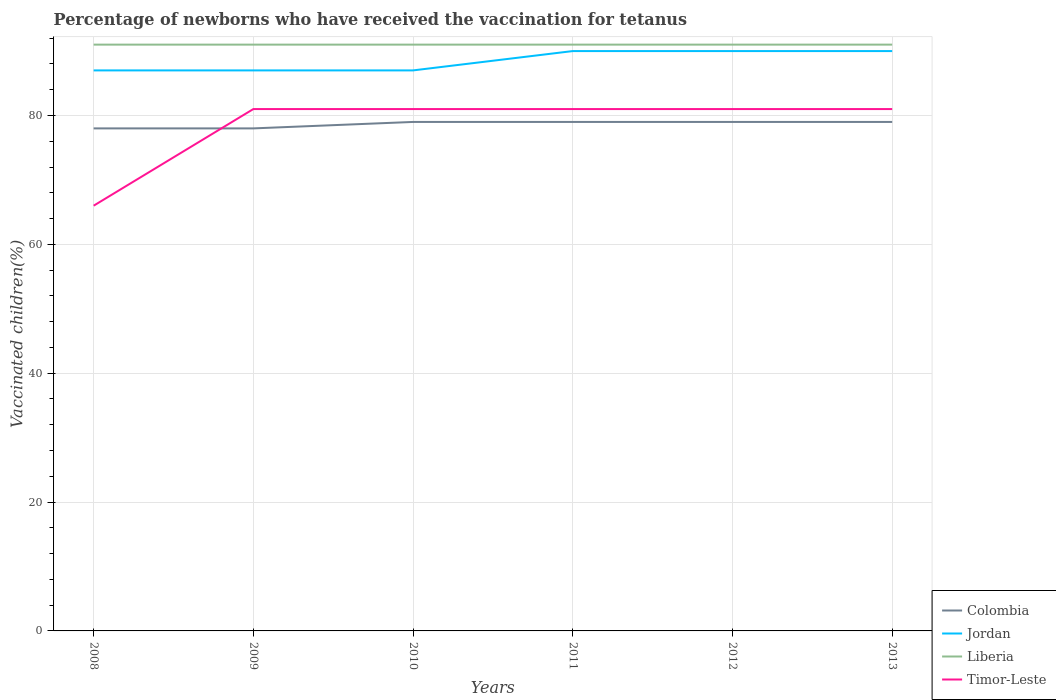How many lines are there?
Offer a very short reply. 4. Does the graph contain any zero values?
Your answer should be very brief. No. Where does the legend appear in the graph?
Your response must be concise. Bottom right. What is the title of the graph?
Give a very brief answer. Percentage of newborns who have received the vaccination for tetanus. Does "Nicaragua" appear as one of the legend labels in the graph?
Offer a very short reply. No. What is the label or title of the Y-axis?
Offer a terse response. Vaccinated children(%). What is the Vaccinated children(%) of Jordan in 2008?
Your response must be concise. 87. What is the Vaccinated children(%) of Liberia in 2008?
Your answer should be compact. 91. What is the Vaccinated children(%) of Liberia in 2009?
Give a very brief answer. 91. What is the Vaccinated children(%) of Timor-Leste in 2009?
Ensure brevity in your answer.  81. What is the Vaccinated children(%) of Colombia in 2010?
Your response must be concise. 79. What is the Vaccinated children(%) in Liberia in 2010?
Provide a succinct answer. 91. What is the Vaccinated children(%) of Timor-Leste in 2010?
Make the answer very short. 81. What is the Vaccinated children(%) in Colombia in 2011?
Make the answer very short. 79. What is the Vaccinated children(%) of Liberia in 2011?
Your answer should be compact. 91. What is the Vaccinated children(%) in Timor-Leste in 2011?
Provide a succinct answer. 81. What is the Vaccinated children(%) of Colombia in 2012?
Provide a succinct answer. 79. What is the Vaccinated children(%) of Jordan in 2012?
Your response must be concise. 90. What is the Vaccinated children(%) in Liberia in 2012?
Your response must be concise. 91. What is the Vaccinated children(%) of Timor-Leste in 2012?
Make the answer very short. 81. What is the Vaccinated children(%) of Colombia in 2013?
Offer a very short reply. 79. What is the Vaccinated children(%) of Jordan in 2013?
Provide a succinct answer. 90. What is the Vaccinated children(%) in Liberia in 2013?
Provide a short and direct response. 91. Across all years, what is the maximum Vaccinated children(%) in Colombia?
Provide a short and direct response. 79. Across all years, what is the maximum Vaccinated children(%) of Liberia?
Provide a succinct answer. 91. Across all years, what is the minimum Vaccinated children(%) in Jordan?
Keep it short and to the point. 87. Across all years, what is the minimum Vaccinated children(%) of Liberia?
Make the answer very short. 91. What is the total Vaccinated children(%) in Colombia in the graph?
Make the answer very short. 472. What is the total Vaccinated children(%) of Jordan in the graph?
Keep it short and to the point. 531. What is the total Vaccinated children(%) of Liberia in the graph?
Provide a short and direct response. 546. What is the total Vaccinated children(%) in Timor-Leste in the graph?
Make the answer very short. 471. What is the difference between the Vaccinated children(%) in Colombia in 2008 and that in 2009?
Keep it short and to the point. 0. What is the difference between the Vaccinated children(%) of Jordan in 2008 and that in 2009?
Your answer should be very brief. 0. What is the difference between the Vaccinated children(%) in Liberia in 2008 and that in 2009?
Provide a succinct answer. 0. What is the difference between the Vaccinated children(%) of Colombia in 2008 and that in 2010?
Provide a succinct answer. -1. What is the difference between the Vaccinated children(%) in Jordan in 2008 and that in 2010?
Offer a terse response. 0. What is the difference between the Vaccinated children(%) in Timor-Leste in 2008 and that in 2010?
Your response must be concise. -15. What is the difference between the Vaccinated children(%) of Timor-Leste in 2008 and that in 2011?
Give a very brief answer. -15. What is the difference between the Vaccinated children(%) in Colombia in 2008 and that in 2012?
Offer a very short reply. -1. What is the difference between the Vaccinated children(%) of Jordan in 2008 and that in 2012?
Your answer should be compact. -3. What is the difference between the Vaccinated children(%) in Liberia in 2008 and that in 2012?
Offer a very short reply. 0. What is the difference between the Vaccinated children(%) of Timor-Leste in 2008 and that in 2012?
Offer a terse response. -15. What is the difference between the Vaccinated children(%) in Colombia in 2008 and that in 2013?
Ensure brevity in your answer.  -1. What is the difference between the Vaccinated children(%) of Colombia in 2009 and that in 2010?
Your answer should be very brief. -1. What is the difference between the Vaccinated children(%) in Jordan in 2009 and that in 2011?
Offer a terse response. -3. What is the difference between the Vaccinated children(%) in Liberia in 2009 and that in 2011?
Give a very brief answer. 0. What is the difference between the Vaccinated children(%) in Jordan in 2009 and that in 2012?
Offer a very short reply. -3. What is the difference between the Vaccinated children(%) of Liberia in 2009 and that in 2012?
Ensure brevity in your answer.  0. What is the difference between the Vaccinated children(%) in Timor-Leste in 2009 and that in 2012?
Offer a very short reply. 0. What is the difference between the Vaccinated children(%) in Colombia in 2009 and that in 2013?
Offer a terse response. -1. What is the difference between the Vaccinated children(%) of Jordan in 2009 and that in 2013?
Your answer should be compact. -3. What is the difference between the Vaccinated children(%) in Timor-Leste in 2009 and that in 2013?
Your answer should be very brief. 0. What is the difference between the Vaccinated children(%) of Colombia in 2010 and that in 2012?
Offer a very short reply. 0. What is the difference between the Vaccinated children(%) in Jordan in 2010 and that in 2012?
Your response must be concise. -3. What is the difference between the Vaccinated children(%) in Colombia in 2010 and that in 2013?
Offer a very short reply. 0. What is the difference between the Vaccinated children(%) of Jordan in 2010 and that in 2013?
Give a very brief answer. -3. What is the difference between the Vaccinated children(%) of Liberia in 2010 and that in 2013?
Give a very brief answer. 0. What is the difference between the Vaccinated children(%) in Jordan in 2011 and that in 2012?
Provide a short and direct response. 0. What is the difference between the Vaccinated children(%) of Colombia in 2012 and that in 2013?
Make the answer very short. 0. What is the difference between the Vaccinated children(%) of Jordan in 2012 and that in 2013?
Offer a terse response. 0. What is the difference between the Vaccinated children(%) in Liberia in 2012 and that in 2013?
Offer a terse response. 0. What is the difference between the Vaccinated children(%) of Timor-Leste in 2012 and that in 2013?
Keep it short and to the point. 0. What is the difference between the Vaccinated children(%) of Colombia in 2008 and the Vaccinated children(%) of Jordan in 2009?
Give a very brief answer. -9. What is the difference between the Vaccinated children(%) in Colombia in 2008 and the Vaccinated children(%) in Liberia in 2009?
Your response must be concise. -13. What is the difference between the Vaccinated children(%) of Colombia in 2008 and the Vaccinated children(%) of Timor-Leste in 2009?
Your answer should be very brief. -3. What is the difference between the Vaccinated children(%) of Liberia in 2008 and the Vaccinated children(%) of Timor-Leste in 2009?
Ensure brevity in your answer.  10. What is the difference between the Vaccinated children(%) in Colombia in 2008 and the Vaccinated children(%) in Timor-Leste in 2010?
Offer a terse response. -3. What is the difference between the Vaccinated children(%) of Jordan in 2008 and the Vaccinated children(%) of Timor-Leste in 2010?
Offer a very short reply. 6. What is the difference between the Vaccinated children(%) in Colombia in 2008 and the Vaccinated children(%) in Liberia in 2011?
Offer a very short reply. -13. What is the difference between the Vaccinated children(%) of Colombia in 2008 and the Vaccinated children(%) of Timor-Leste in 2011?
Offer a very short reply. -3. What is the difference between the Vaccinated children(%) in Jordan in 2008 and the Vaccinated children(%) in Timor-Leste in 2011?
Give a very brief answer. 6. What is the difference between the Vaccinated children(%) in Colombia in 2008 and the Vaccinated children(%) in Jordan in 2012?
Your answer should be compact. -12. What is the difference between the Vaccinated children(%) in Colombia in 2008 and the Vaccinated children(%) in Liberia in 2012?
Offer a terse response. -13. What is the difference between the Vaccinated children(%) of Colombia in 2008 and the Vaccinated children(%) of Timor-Leste in 2012?
Your response must be concise. -3. What is the difference between the Vaccinated children(%) of Jordan in 2008 and the Vaccinated children(%) of Timor-Leste in 2012?
Ensure brevity in your answer.  6. What is the difference between the Vaccinated children(%) in Liberia in 2008 and the Vaccinated children(%) in Timor-Leste in 2012?
Keep it short and to the point. 10. What is the difference between the Vaccinated children(%) of Colombia in 2008 and the Vaccinated children(%) of Liberia in 2013?
Your answer should be compact. -13. What is the difference between the Vaccinated children(%) of Colombia in 2008 and the Vaccinated children(%) of Timor-Leste in 2013?
Your answer should be compact. -3. What is the difference between the Vaccinated children(%) in Colombia in 2009 and the Vaccinated children(%) in Liberia in 2010?
Your answer should be compact. -13. What is the difference between the Vaccinated children(%) in Colombia in 2009 and the Vaccinated children(%) in Timor-Leste in 2010?
Offer a terse response. -3. What is the difference between the Vaccinated children(%) in Jordan in 2009 and the Vaccinated children(%) in Liberia in 2010?
Give a very brief answer. -4. What is the difference between the Vaccinated children(%) in Jordan in 2009 and the Vaccinated children(%) in Timor-Leste in 2010?
Keep it short and to the point. 6. What is the difference between the Vaccinated children(%) in Colombia in 2009 and the Vaccinated children(%) in Liberia in 2011?
Provide a short and direct response. -13. What is the difference between the Vaccinated children(%) of Colombia in 2009 and the Vaccinated children(%) of Timor-Leste in 2011?
Your answer should be very brief. -3. What is the difference between the Vaccinated children(%) of Jordan in 2009 and the Vaccinated children(%) of Timor-Leste in 2011?
Your answer should be very brief. 6. What is the difference between the Vaccinated children(%) in Liberia in 2009 and the Vaccinated children(%) in Timor-Leste in 2011?
Offer a very short reply. 10. What is the difference between the Vaccinated children(%) of Colombia in 2009 and the Vaccinated children(%) of Liberia in 2012?
Offer a terse response. -13. What is the difference between the Vaccinated children(%) in Colombia in 2009 and the Vaccinated children(%) in Timor-Leste in 2012?
Keep it short and to the point. -3. What is the difference between the Vaccinated children(%) in Jordan in 2009 and the Vaccinated children(%) in Liberia in 2012?
Your answer should be compact. -4. What is the difference between the Vaccinated children(%) of Jordan in 2009 and the Vaccinated children(%) of Timor-Leste in 2012?
Your answer should be compact. 6. What is the difference between the Vaccinated children(%) of Liberia in 2009 and the Vaccinated children(%) of Timor-Leste in 2012?
Your response must be concise. 10. What is the difference between the Vaccinated children(%) of Colombia in 2009 and the Vaccinated children(%) of Liberia in 2013?
Provide a short and direct response. -13. What is the difference between the Vaccinated children(%) of Colombia in 2009 and the Vaccinated children(%) of Timor-Leste in 2013?
Give a very brief answer. -3. What is the difference between the Vaccinated children(%) of Jordan in 2009 and the Vaccinated children(%) of Liberia in 2013?
Offer a very short reply. -4. What is the difference between the Vaccinated children(%) of Jordan in 2009 and the Vaccinated children(%) of Timor-Leste in 2013?
Provide a succinct answer. 6. What is the difference between the Vaccinated children(%) of Liberia in 2009 and the Vaccinated children(%) of Timor-Leste in 2013?
Your answer should be very brief. 10. What is the difference between the Vaccinated children(%) of Colombia in 2010 and the Vaccinated children(%) of Jordan in 2011?
Provide a succinct answer. -11. What is the difference between the Vaccinated children(%) of Colombia in 2010 and the Vaccinated children(%) of Liberia in 2011?
Offer a terse response. -12. What is the difference between the Vaccinated children(%) in Jordan in 2010 and the Vaccinated children(%) in Liberia in 2011?
Your response must be concise. -4. What is the difference between the Vaccinated children(%) in Jordan in 2010 and the Vaccinated children(%) in Timor-Leste in 2011?
Provide a succinct answer. 6. What is the difference between the Vaccinated children(%) of Colombia in 2010 and the Vaccinated children(%) of Jordan in 2012?
Your answer should be compact. -11. What is the difference between the Vaccinated children(%) in Jordan in 2010 and the Vaccinated children(%) in Liberia in 2012?
Your answer should be compact. -4. What is the difference between the Vaccinated children(%) in Jordan in 2010 and the Vaccinated children(%) in Timor-Leste in 2012?
Your answer should be very brief. 6. What is the difference between the Vaccinated children(%) in Colombia in 2010 and the Vaccinated children(%) in Jordan in 2013?
Keep it short and to the point. -11. What is the difference between the Vaccinated children(%) of Jordan in 2010 and the Vaccinated children(%) of Liberia in 2013?
Provide a succinct answer. -4. What is the difference between the Vaccinated children(%) in Jordan in 2010 and the Vaccinated children(%) in Timor-Leste in 2013?
Your response must be concise. 6. What is the difference between the Vaccinated children(%) of Liberia in 2010 and the Vaccinated children(%) of Timor-Leste in 2013?
Offer a terse response. 10. What is the difference between the Vaccinated children(%) of Colombia in 2011 and the Vaccinated children(%) of Jordan in 2012?
Your answer should be compact. -11. What is the difference between the Vaccinated children(%) of Colombia in 2011 and the Vaccinated children(%) of Liberia in 2012?
Make the answer very short. -12. What is the difference between the Vaccinated children(%) in Jordan in 2011 and the Vaccinated children(%) in Timor-Leste in 2012?
Offer a terse response. 9. What is the difference between the Vaccinated children(%) in Liberia in 2011 and the Vaccinated children(%) in Timor-Leste in 2012?
Make the answer very short. 10. What is the difference between the Vaccinated children(%) of Colombia in 2011 and the Vaccinated children(%) of Jordan in 2013?
Ensure brevity in your answer.  -11. What is the difference between the Vaccinated children(%) of Jordan in 2011 and the Vaccinated children(%) of Liberia in 2013?
Keep it short and to the point. -1. What is the difference between the Vaccinated children(%) in Jordan in 2011 and the Vaccinated children(%) in Timor-Leste in 2013?
Offer a very short reply. 9. What is the difference between the Vaccinated children(%) in Liberia in 2011 and the Vaccinated children(%) in Timor-Leste in 2013?
Offer a terse response. 10. What is the difference between the Vaccinated children(%) in Colombia in 2012 and the Vaccinated children(%) in Jordan in 2013?
Ensure brevity in your answer.  -11. What is the difference between the Vaccinated children(%) in Colombia in 2012 and the Vaccinated children(%) in Timor-Leste in 2013?
Provide a succinct answer. -2. What is the difference between the Vaccinated children(%) of Jordan in 2012 and the Vaccinated children(%) of Timor-Leste in 2013?
Make the answer very short. 9. What is the difference between the Vaccinated children(%) in Liberia in 2012 and the Vaccinated children(%) in Timor-Leste in 2013?
Offer a terse response. 10. What is the average Vaccinated children(%) in Colombia per year?
Your response must be concise. 78.67. What is the average Vaccinated children(%) of Jordan per year?
Your answer should be very brief. 88.5. What is the average Vaccinated children(%) in Liberia per year?
Offer a very short reply. 91. What is the average Vaccinated children(%) in Timor-Leste per year?
Ensure brevity in your answer.  78.5. In the year 2008, what is the difference between the Vaccinated children(%) of Colombia and Vaccinated children(%) of Liberia?
Offer a very short reply. -13. In the year 2008, what is the difference between the Vaccinated children(%) in Jordan and Vaccinated children(%) in Liberia?
Provide a short and direct response. -4. In the year 2008, what is the difference between the Vaccinated children(%) in Jordan and Vaccinated children(%) in Timor-Leste?
Your answer should be very brief. 21. In the year 2008, what is the difference between the Vaccinated children(%) in Liberia and Vaccinated children(%) in Timor-Leste?
Provide a short and direct response. 25. In the year 2009, what is the difference between the Vaccinated children(%) of Colombia and Vaccinated children(%) of Jordan?
Make the answer very short. -9. In the year 2009, what is the difference between the Vaccinated children(%) of Colombia and Vaccinated children(%) of Timor-Leste?
Offer a very short reply. -3. In the year 2009, what is the difference between the Vaccinated children(%) of Jordan and Vaccinated children(%) of Timor-Leste?
Your answer should be very brief. 6. In the year 2010, what is the difference between the Vaccinated children(%) of Liberia and Vaccinated children(%) of Timor-Leste?
Make the answer very short. 10. In the year 2011, what is the difference between the Vaccinated children(%) of Colombia and Vaccinated children(%) of Timor-Leste?
Provide a short and direct response. -2. In the year 2011, what is the difference between the Vaccinated children(%) of Jordan and Vaccinated children(%) of Liberia?
Your response must be concise. -1. In the year 2012, what is the difference between the Vaccinated children(%) in Colombia and Vaccinated children(%) in Liberia?
Make the answer very short. -12. In the year 2012, what is the difference between the Vaccinated children(%) in Jordan and Vaccinated children(%) in Liberia?
Give a very brief answer. -1. In the year 2012, what is the difference between the Vaccinated children(%) in Jordan and Vaccinated children(%) in Timor-Leste?
Your answer should be compact. 9. In the year 2013, what is the difference between the Vaccinated children(%) in Colombia and Vaccinated children(%) in Liberia?
Offer a terse response. -12. In the year 2013, what is the difference between the Vaccinated children(%) of Jordan and Vaccinated children(%) of Timor-Leste?
Provide a short and direct response. 9. In the year 2013, what is the difference between the Vaccinated children(%) in Liberia and Vaccinated children(%) in Timor-Leste?
Ensure brevity in your answer.  10. What is the ratio of the Vaccinated children(%) of Liberia in 2008 to that in 2009?
Give a very brief answer. 1. What is the ratio of the Vaccinated children(%) of Timor-Leste in 2008 to that in 2009?
Your answer should be compact. 0.81. What is the ratio of the Vaccinated children(%) of Colombia in 2008 to that in 2010?
Provide a succinct answer. 0.99. What is the ratio of the Vaccinated children(%) in Timor-Leste in 2008 to that in 2010?
Give a very brief answer. 0.81. What is the ratio of the Vaccinated children(%) in Colombia in 2008 to that in 2011?
Your answer should be very brief. 0.99. What is the ratio of the Vaccinated children(%) in Jordan in 2008 to that in 2011?
Offer a terse response. 0.97. What is the ratio of the Vaccinated children(%) of Timor-Leste in 2008 to that in 2011?
Provide a short and direct response. 0.81. What is the ratio of the Vaccinated children(%) in Colombia in 2008 to that in 2012?
Your answer should be very brief. 0.99. What is the ratio of the Vaccinated children(%) in Jordan in 2008 to that in 2012?
Your answer should be very brief. 0.97. What is the ratio of the Vaccinated children(%) in Timor-Leste in 2008 to that in 2012?
Make the answer very short. 0.81. What is the ratio of the Vaccinated children(%) of Colombia in 2008 to that in 2013?
Offer a terse response. 0.99. What is the ratio of the Vaccinated children(%) in Jordan in 2008 to that in 2013?
Your answer should be compact. 0.97. What is the ratio of the Vaccinated children(%) in Timor-Leste in 2008 to that in 2013?
Make the answer very short. 0.81. What is the ratio of the Vaccinated children(%) of Colombia in 2009 to that in 2010?
Provide a short and direct response. 0.99. What is the ratio of the Vaccinated children(%) in Jordan in 2009 to that in 2010?
Your answer should be compact. 1. What is the ratio of the Vaccinated children(%) of Colombia in 2009 to that in 2011?
Keep it short and to the point. 0.99. What is the ratio of the Vaccinated children(%) of Jordan in 2009 to that in 2011?
Offer a very short reply. 0.97. What is the ratio of the Vaccinated children(%) of Liberia in 2009 to that in 2011?
Offer a terse response. 1. What is the ratio of the Vaccinated children(%) in Colombia in 2009 to that in 2012?
Provide a succinct answer. 0.99. What is the ratio of the Vaccinated children(%) of Jordan in 2009 to that in 2012?
Ensure brevity in your answer.  0.97. What is the ratio of the Vaccinated children(%) of Timor-Leste in 2009 to that in 2012?
Your answer should be very brief. 1. What is the ratio of the Vaccinated children(%) of Colombia in 2009 to that in 2013?
Offer a terse response. 0.99. What is the ratio of the Vaccinated children(%) in Jordan in 2009 to that in 2013?
Offer a terse response. 0.97. What is the ratio of the Vaccinated children(%) in Liberia in 2009 to that in 2013?
Offer a terse response. 1. What is the ratio of the Vaccinated children(%) of Timor-Leste in 2009 to that in 2013?
Keep it short and to the point. 1. What is the ratio of the Vaccinated children(%) of Colombia in 2010 to that in 2011?
Your answer should be very brief. 1. What is the ratio of the Vaccinated children(%) of Jordan in 2010 to that in 2011?
Provide a succinct answer. 0.97. What is the ratio of the Vaccinated children(%) in Liberia in 2010 to that in 2011?
Your answer should be compact. 1. What is the ratio of the Vaccinated children(%) of Timor-Leste in 2010 to that in 2011?
Ensure brevity in your answer.  1. What is the ratio of the Vaccinated children(%) of Colombia in 2010 to that in 2012?
Your answer should be very brief. 1. What is the ratio of the Vaccinated children(%) in Jordan in 2010 to that in 2012?
Offer a terse response. 0.97. What is the ratio of the Vaccinated children(%) of Jordan in 2010 to that in 2013?
Offer a very short reply. 0.97. What is the ratio of the Vaccinated children(%) in Timor-Leste in 2010 to that in 2013?
Ensure brevity in your answer.  1. What is the ratio of the Vaccinated children(%) in Liberia in 2011 to that in 2012?
Give a very brief answer. 1. What is the ratio of the Vaccinated children(%) of Timor-Leste in 2011 to that in 2013?
Offer a terse response. 1. What is the ratio of the Vaccinated children(%) in Jordan in 2012 to that in 2013?
Make the answer very short. 1. What is the ratio of the Vaccinated children(%) of Timor-Leste in 2012 to that in 2013?
Ensure brevity in your answer.  1. What is the difference between the highest and the second highest Vaccinated children(%) of Liberia?
Your response must be concise. 0. What is the difference between the highest and the second highest Vaccinated children(%) in Timor-Leste?
Ensure brevity in your answer.  0. What is the difference between the highest and the lowest Vaccinated children(%) of Colombia?
Make the answer very short. 1. What is the difference between the highest and the lowest Vaccinated children(%) in Timor-Leste?
Ensure brevity in your answer.  15. 